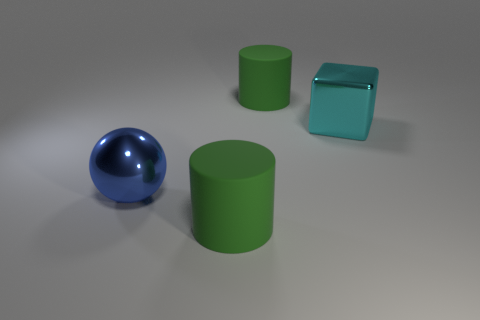Are there the same number of blocks in front of the large ball and green objects?
Provide a succinct answer. No. What number of large cyan objects are the same shape as the large blue metallic thing?
Make the answer very short. 0. There is a rubber thing in front of the green matte thing right of the object in front of the blue sphere; how big is it?
Make the answer very short. Large. Is the big green thing that is in front of the big cyan block made of the same material as the large cyan cube?
Your answer should be very brief. No. Are there the same number of green objects that are on the left side of the large blue shiny ball and blue metal things behind the big cyan shiny cube?
Your answer should be compact. Yes. Is there anything else that has the same size as the metallic sphere?
Your answer should be compact. Yes. There is a large green rubber thing that is on the left side of the big green rubber thing behind the blue shiny thing; are there any blue shiny objects that are in front of it?
Provide a short and direct response. No. There is a large green rubber object in front of the blue thing; is it the same shape as the rubber object behind the big blue thing?
Keep it short and to the point. Yes. Is the number of big green rubber objects that are in front of the blue metal thing greater than the number of green cylinders?
Your response must be concise. No. What number of things are large things or big cyan cylinders?
Make the answer very short. 4. 